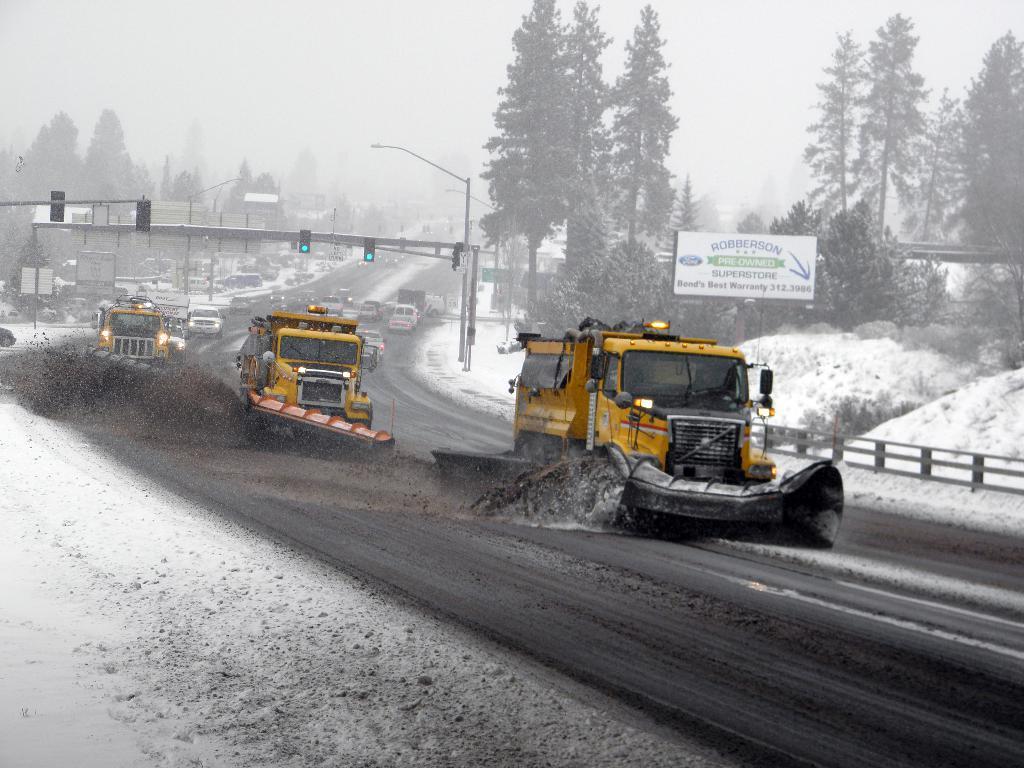Could you give a brief overview of what you see in this image? This picture is clicked outside. In the center we can see the group of vehicles and we can see there are some objects lying on the ground. In the background we can see the sky, trees, traffic lights, street light, railings, text on the board and we can see the snow and many other objects. 